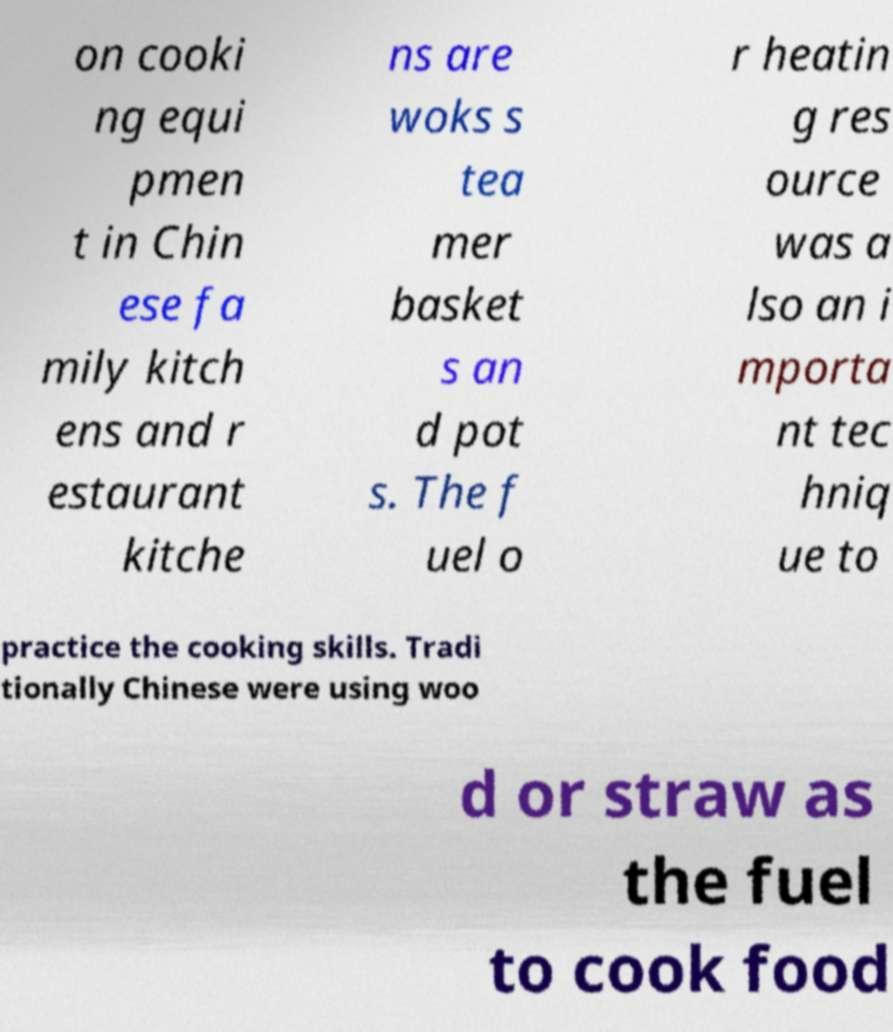For documentation purposes, I need the text within this image transcribed. Could you provide that? on cooki ng equi pmen t in Chin ese fa mily kitch ens and r estaurant kitche ns are woks s tea mer basket s an d pot s. The f uel o r heatin g res ource was a lso an i mporta nt tec hniq ue to practice the cooking skills. Tradi tionally Chinese were using woo d or straw as the fuel to cook food 